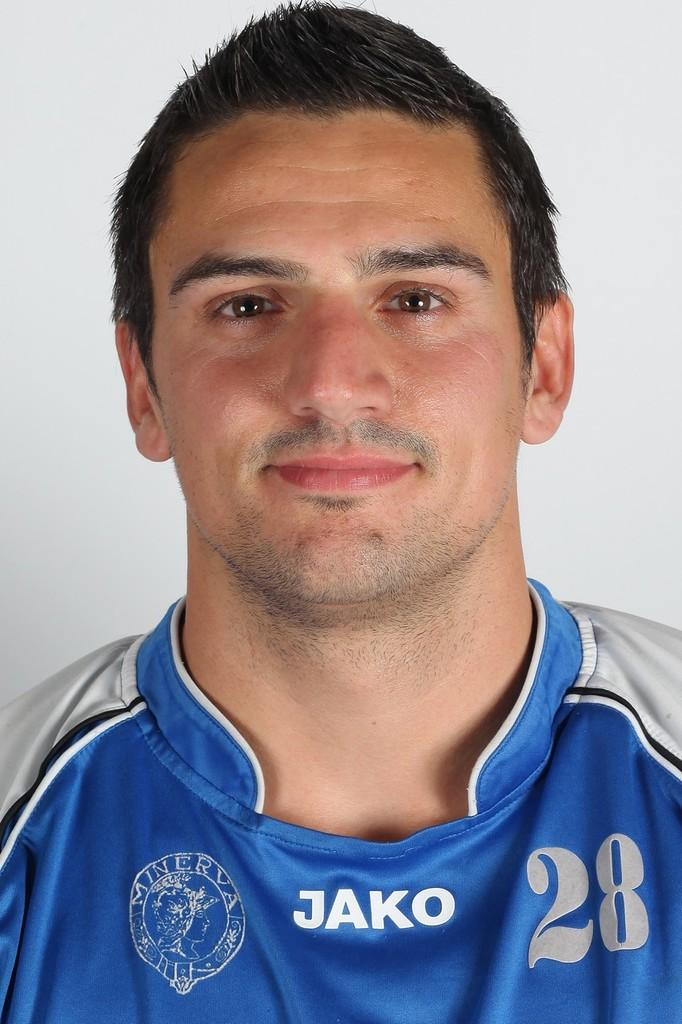Who is present in the image? There is a man in the image. What is the man wearing? The man is wearing a blue color jersey. What can be seen in the background of the image? There is a wall in the background of the image. What is the color of the wall? The wall is white in color. How many crows are sitting on the man's shoulder in the image? There are no crows present in the image. What type of profit can be seen being made by the man in the image? There is no indication of profit or any financial activity in the image. 